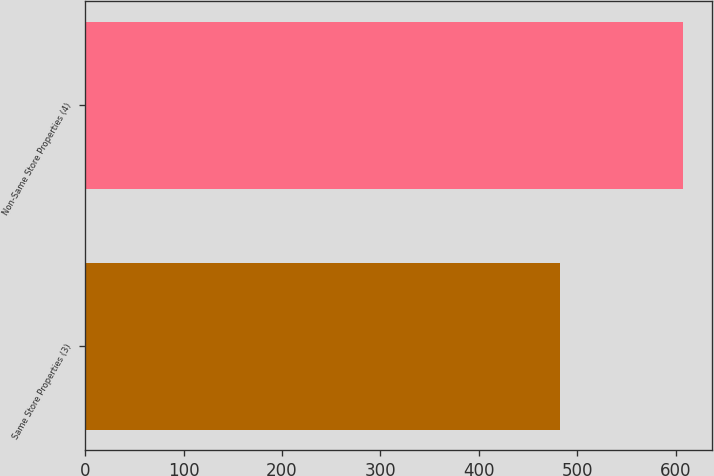Convert chart. <chart><loc_0><loc_0><loc_500><loc_500><bar_chart><fcel>Same Store Properties (3)<fcel>Non-Same Store Properties (4)<nl><fcel>483<fcel>607<nl></chart> 